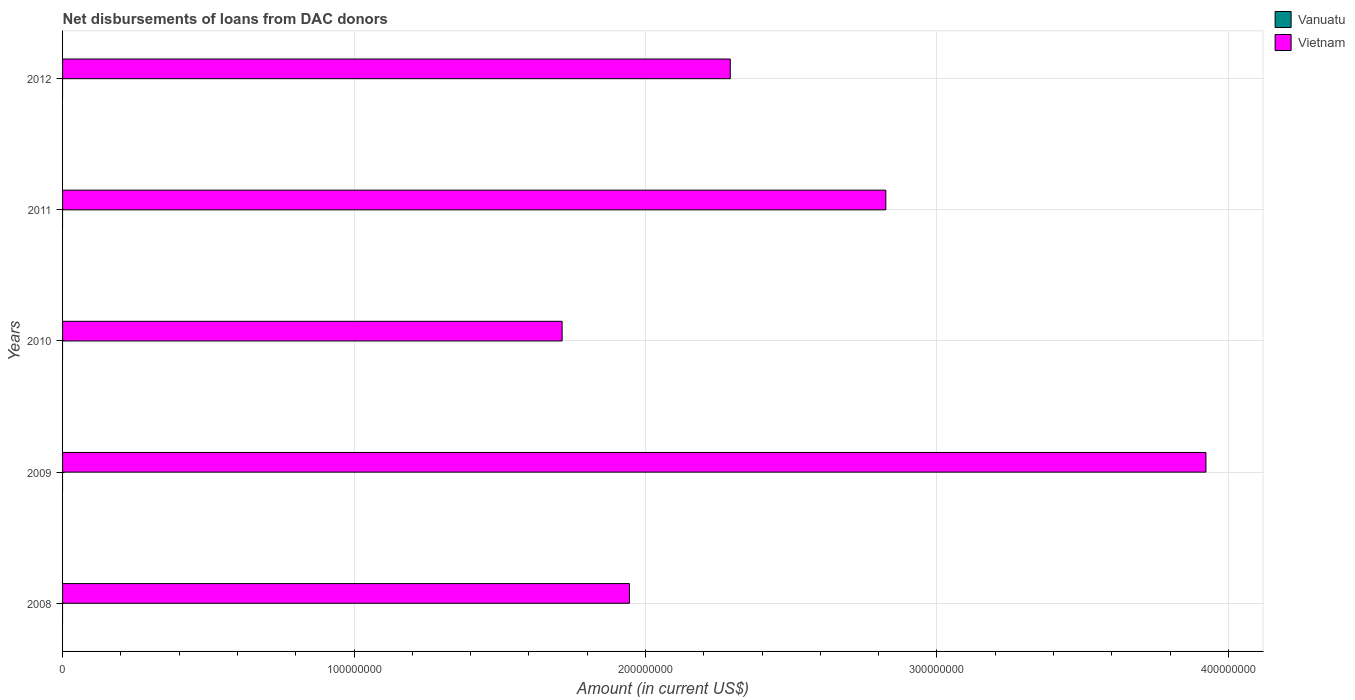Across all years, what is the maximum amount of loans disbursed in Vietnam?
Offer a very short reply. 3.92e+08. Across all years, what is the minimum amount of loans disbursed in Vanuatu?
Offer a very short reply. 0. What is the total amount of loans disbursed in Vanuatu in the graph?
Ensure brevity in your answer.  0. What is the difference between the amount of loans disbursed in Vietnam in 2008 and that in 2011?
Provide a short and direct response. -8.80e+07. What is the difference between the amount of loans disbursed in Vanuatu in 2008 and the amount of loans disbursed in Vietnam in 2012?
Offer a terse response. -2.29e+08. What is the average amount of loans disbursed in Vietnam per year?
Provide a succinct answer. 2.54e+08. In how many years, is the amount of loans disbursed in Vanuatu greater than 140000000 US$?
Offer a terse response. 0. What is the ratio of the amount of loans disbursed in Vietnam in 2008 to that in 2012?
Make the answer very short. 0.85. Is the amount of loans disbursed in Vietnam in 2009 less than that in 2011?
Your answer should be very brief. No. What is the difference between the highest and the second highest amount of loans disbursed in Vietnam?
Provide a succinct answer. 1.10e+08. What is the difference between the highest and the lowest amount of loans disbursed in Vietnam?
Your response must be concise. 2.21e+08. In how many years, is the amount of loans disbursed in Vanuatu greater than the average amount of loans disbursed in Vanuatu taken over all years?
Your answer should be very brief. 0. Are all the bars in the graph horizontal?
Offer a very short reply. Yes. What is the difference between two consecutive major ticks on the X-axis?
Your answer should be very brief. 1.00e+08. Are the values on the major ticks of X-axis written in scientific E-notation?
Your response must be concise. No. Does the graph contain any zero values?
Provide a succinct answer. Yes. Does the graph contain grids?
Your response must be concise. Yes. How many legend labels are there?
Give a very brief answer. 2. How are the legend labels stacked?
Provide a short and direct response. Vertical. What is the title of the graph?
Offer a terse response. Net disbursements of loans from DAC donors. Does "South Sudan" appear as one of the legend labels in the graph?
Offer a terse response. No. What is the Amount (in current US$) of Vietnam in 2008?
Make the answer very short. 1.95e+08. What is the Amount (in current US$) in Vietnam in 2009?
Make the answer very short. 3.92e+08. What is the Amount (in current US$) in Vietnam in 2010?
Give a very brief answer. 1.71e+08. What is the Amount (in current US$) in Vietnam in 2011?
Provide a succinct answer. 2.82e+08. What is the Amount (in current US$) in Vanuatu in 2012?
Offer a terse response. 0. What is the Amount (in current US$) in Vietnam in 2012?
Keep it short and to the point. 2.29e+08. Across all years, what is the maximum Amount (in current US$) in Vietnam?
Ensure brevity in your answer.  3.92e+08. Across all years, what is the minimum Amount (in current US$) of Vietnam?
Give a very brief answer. 1.71e+08. What is the total Amount (in current US$) in Vanuatu in the graph?
Your response must be concise. 0. What is the total Amount (in current US$) in Vietnam in the graph?
Ensure brevity in your answer.  1.27e+09. What is the difference between the Amount (in current US$) in Vietnam in 2008 and that in 2009?
Make the answer very short. -1.98e+08. What is the difference between the Amount (in current US$) in Vietnam in 2008 and that in 2010?
Keep it short and to the point. 2.31e+07. What is the difference between the Amount (in current US$) of Vietnam in 2008 and that in 2011?
Your response must be concise. -8.80e+07. What is the difference between the Amount (in current US$) of Vietnam in 2008 and that in 2012?
Provide a short and direct response. -3.46e+07. What is the difference between the Amount (in current US$) in Vietnam in 2009 and that in 2010?
Provide a short and direct response. 2.21e+08. What is the difference between the Amount (in current US$) in Vietnam in 2009 and that in 2011?
Make the answer very short. 1.10e+08. What is the difference between the Amount (in current US$) in Vietnam in 2009 and that in 2012?
Offer a terse response. 1.63e+08. What is the difference between the Amount (in current US$) in Vietnam in 2010 and that in 2011?
Make the answer very short. -1.11e+08. What is the difference between the Amount (in current US$) in Vietnam in 2010 and that in 2012?
Keep it short and to the point. -5.77e+07. What is the difference between the Amount (in current US$) in Vietnam in 2011 and that in 2012?
Your response must be concise. 5.34e+07. What is the average Amount (in current US$) in Vanuatu per year?
Offer a very short reply. 0. What is the average Amount (in current US$) of Vietnam per year?
Keep it short and to the point. 2.54e+08. What is the ratio of the Amount (in current US$) of Vietnam in 2008 to that in 2009?
Offer a terse response. 0.5. What is the ratio of the Amount (in current US$) of Vietnam in 2008 to that in 2010?
Offer a very short reply. 1.13. What is the ratio of the Amount (in current US$) in Vietnam in 2008 to that in 2011?
Make the answer very short. 0.69. What is the ratio of the Amount (in current US$) in Vietnam in 2008 to that in 2012?
Ensure brevity in your answer.  0.85. What is the ratio of the Amount (in current US$) in Vietnam in 2009 to that in 2010?
Provide a succinct answer. 2.29. What is the ratio of the Amount (in current US$) of Vietnam in 2009 to that in 2011?
Give a very brief answer. 1.39. What is the ratio of the Amount (in current US$) in Vietnam in 2009 to that in 2012?
Provide a succinct answer. 1.71. What is the ratio of the Amount (in current US$) of Vietnam in 2010 to that in 2011?
Make the answer very short. 0.61. What is the ratio of the Amount (in current US$) of Vietnam in 2010 to that in 2012?
Offer a terse response. 0.75. What is the ratio of the Amount (in current US$) of Vietnam in 2011 to that in 2012?
Your answer should be very brief. 1.23. What is the difference between the highest and the second highest Amount (in current US$) in Vietnam?
Your answer should be very brief. 1.10e+08. What is the difference between the highest and the lowest Amount (in current US$) of Vietnam?
Make the answer very short. 2.21e+08. 